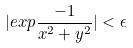Convert formula to latex. <formula><loc_0><loc_0><loc_500><loc_500>| e x p \frac { - 1 } { x ^ { 2 } + y ^ { 2 } } | < \epsilon</formula> 